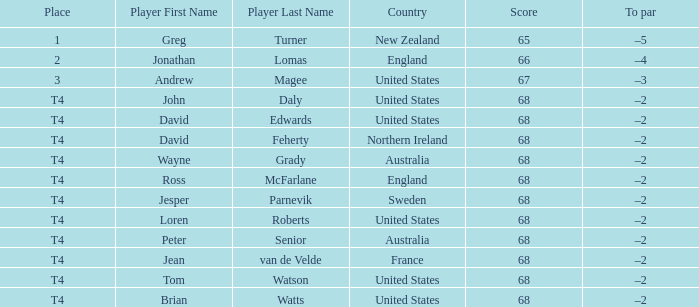Name the Place of england with a Score larger than 66? T4. 